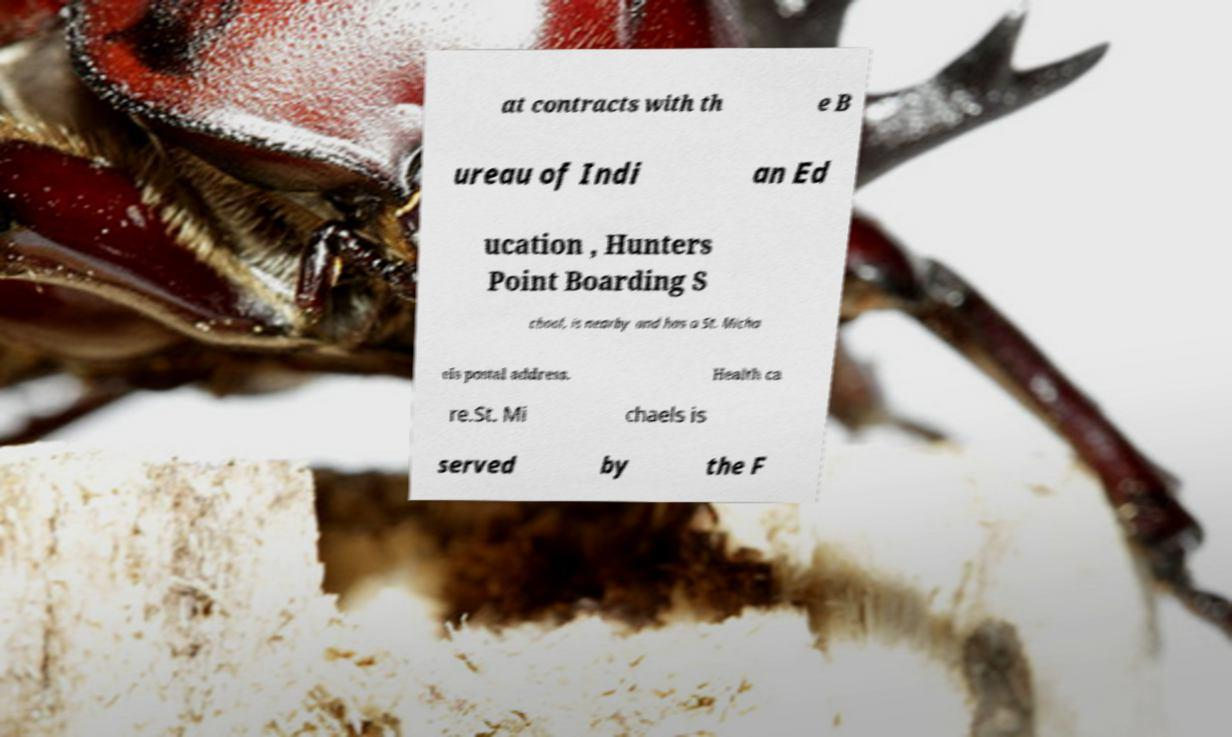For documentation purposes, I need the text within this image transcribed. Could you provide that? at contracts with th e B ureau of Indi an Ed ucation , Hunters Point Boarding S chool, is nearby and has a St. Micha els postal address. Health ca re.St. Mi chaels is served by the F 